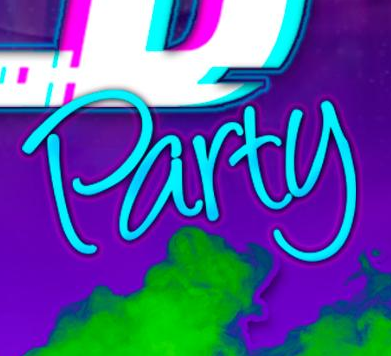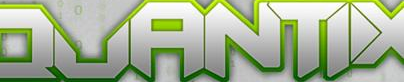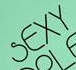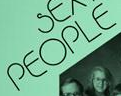Read the text from these images in sequence, separated by a semicolon. Party; QUANTIX; SEXY; PEOPLE 